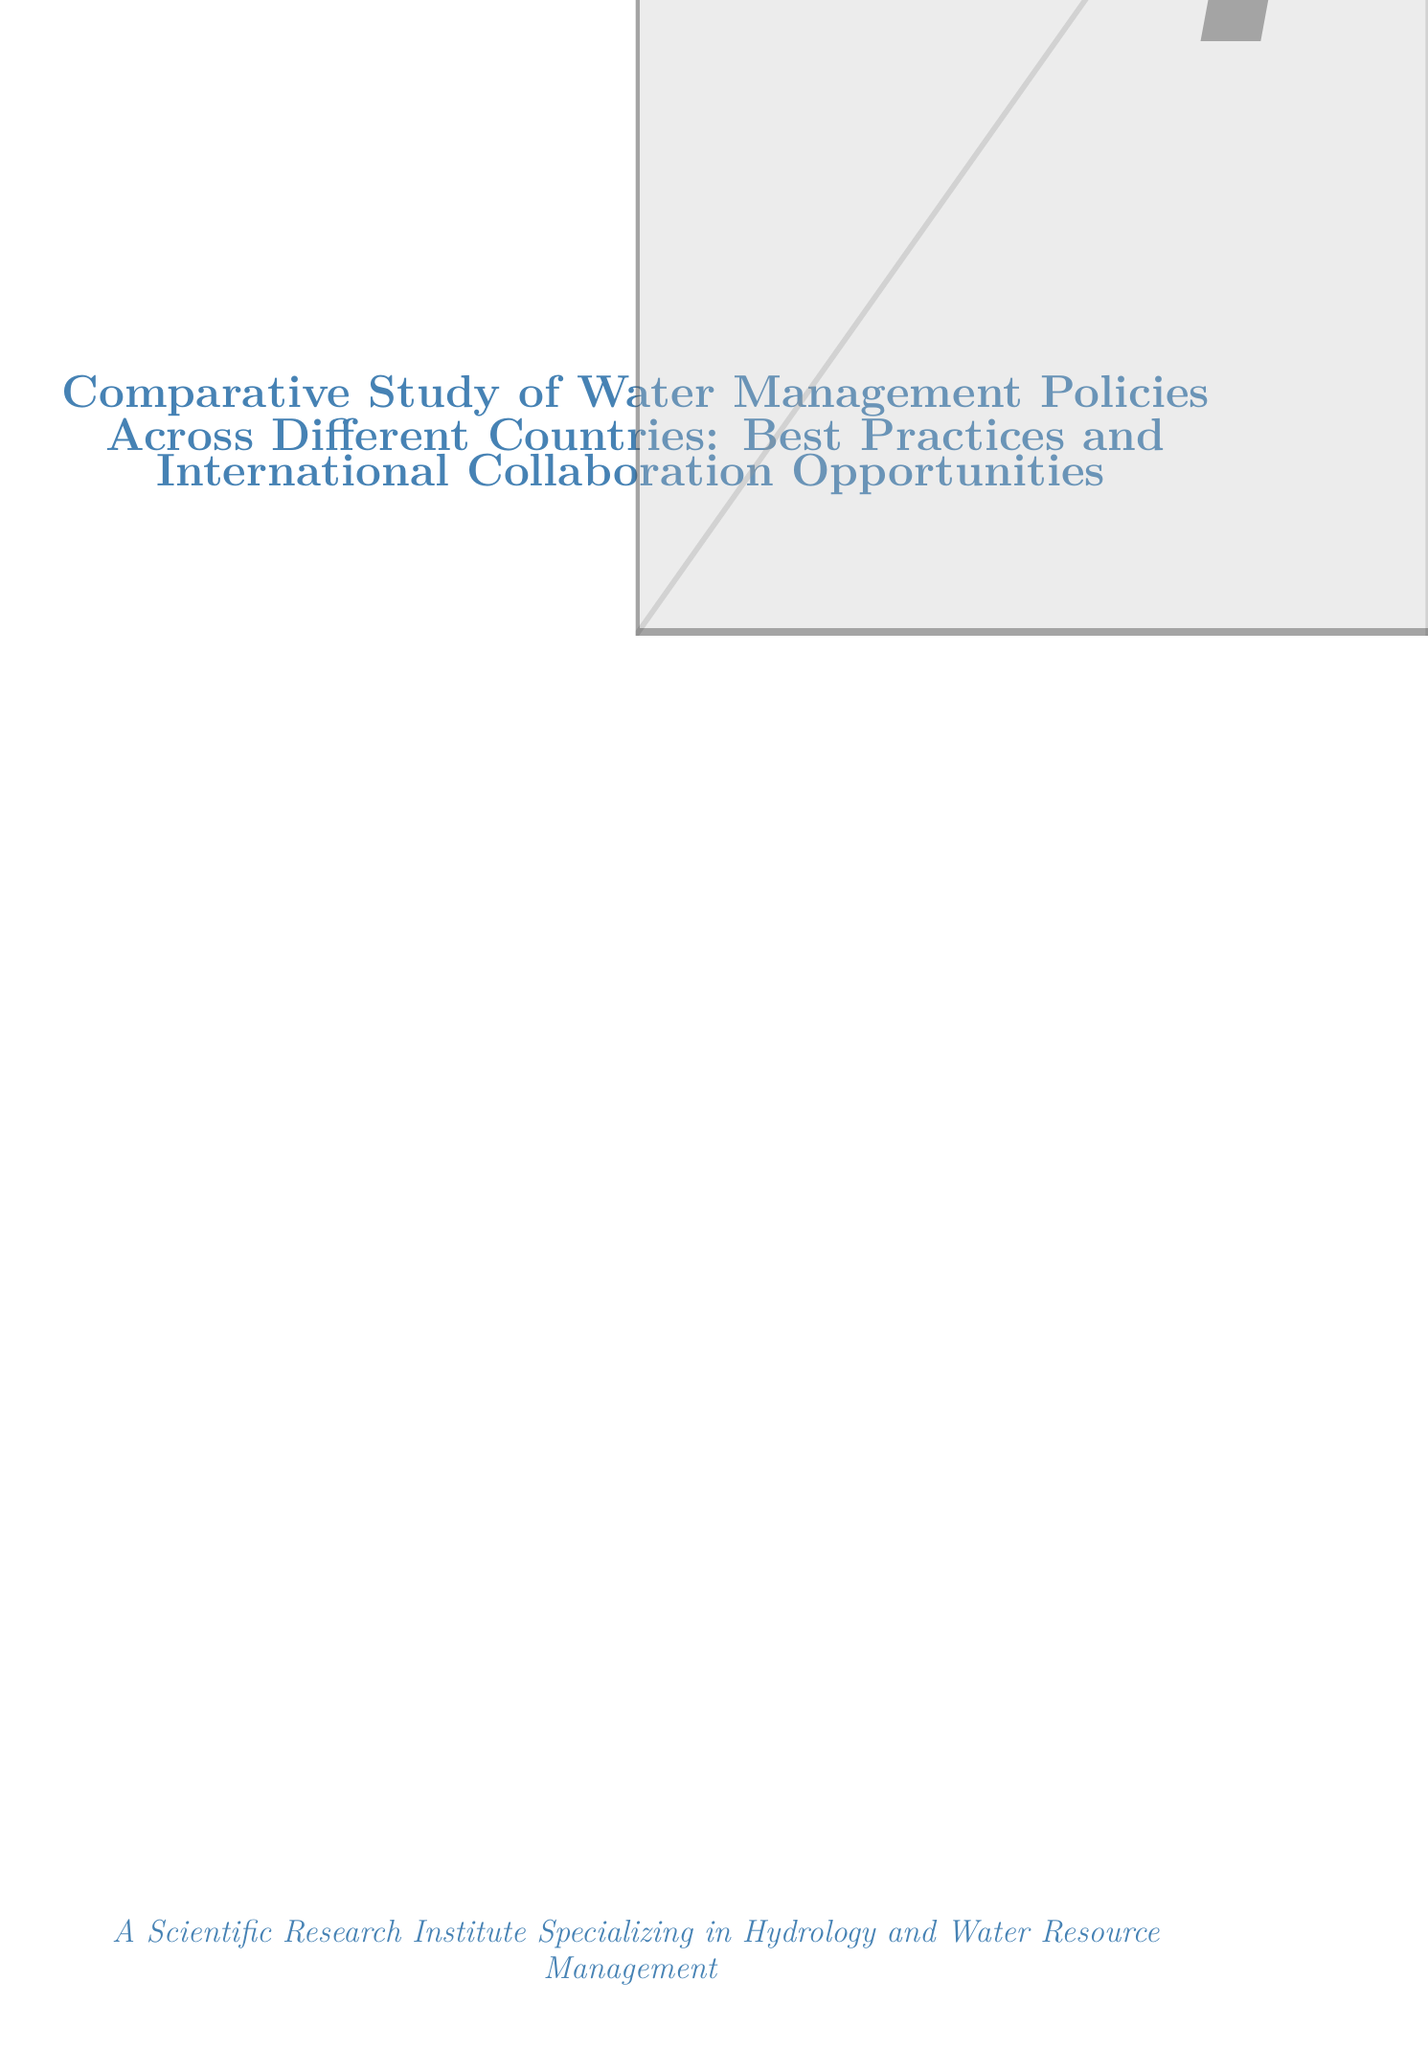What is the title of the report? The title of the report is explicitly stated at the beginning of the document.
Answer: Comparative Study of Water Management Policies Across Different Countries: Best Practices and International Collaboration Opportunities Which countries are analyzed in the study? The document lists the countries analyzed in the section on countries analyzed.
Answer: Australia, Israel, Singapore, Netherlands, United States What is the focus of Israel's water management policy? Each case study includes a specific focus related to that country's water management policy.
Answer: Water resource development and distribution What are the key features of Singapore's Four National Taps strategy? The key features are detailed in the cases studies section under Singapore's strategy.
Answer: NEWater (reclaimed water), Catchment management, Seawater desalination What is an example of a nature-based solution mentioned in the report? Best practices section provides specific examples regarding nature-based solutions.
Answer: Netherlands' Room for the River program How many areas for international collaboration opportunities are identified? The section on international collaboration opportunities lists the number of areas discussed.
Answer: Three Which research institution specializes in flood risk management? The document provides the expertise area for each research institution listed.
Answer: Deltares What is the recommendation related to a global water policy database? The recommendations section clearly states proposals relevant to water management data.
Answer: Establish a global water policy database 